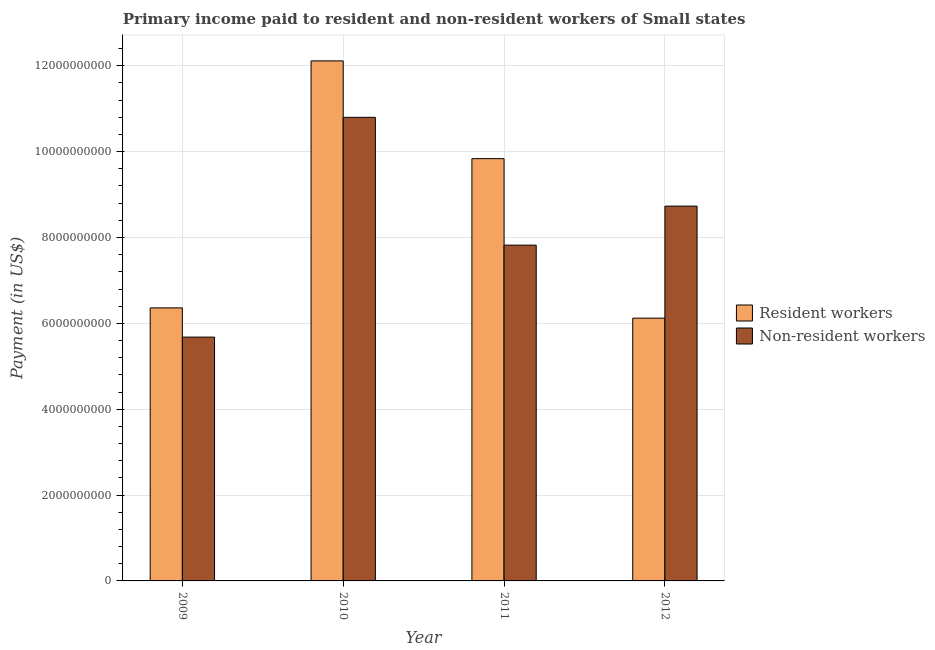How many different coloured bars are there?
Provide a short and direct response. 2. How many groups of bars are there?
Make the answer very short. 4. Are the number of bars per tick equal to the number of legend labels?
Your answer should be compact. Yes. Are the number of bars on each tick of the X-axis equal?
Provide a short and direct response. Yes. How many bars are there on the 3rd tick from the left?
Your response must be concise. 2. What is the label of the 2nd group of bars from the left?
Give a very brief answer. 2010. What is the payment made to resident workers in 2012?
Make the answer very short. 6.12e+09. Across all years, what is the maximum payment made to resident workers?
Offer a terse response. 1.21e+1. Across all years, what is the minimum payment made to non-resident workers?
Your answer should be very brief. 5.68e+09. In which year was the payment made to non-resident workers maximum?
Your answer should be compact. 2010. What is the total payment made to non-resident workers in the graph?
Provide a succinct answer. 3.30e+1. What is the difference between the payment made to non-resident workers in 2010 and that in 2011?
Keep it short and to the point. 2.98e+09. What is the difference between the payment made to non-resident workers in 2010 and the payment made to resident workers in 2009?
Your answer should be very brief. 5.12e+09. What is the average payment made to non-resident workers per year?
Provide a short and direct response. 8.26e+09. In how many years, is the payment made to resident workers greater than 10400000000 US$?
Your response must be concise. 1. What is the ratio of the payment made to non-resident workers in 2010 to that in 2011?
Offer a very short reply. 1.38. Is the payment made to resident workers in 2010 less than that in 2012?
Your answer should be very brief. No. What is the difference between the highest and the second highest payment made to non-resident workers?
Provide a succinct answer. 2.07e+09. What is the difference between the highest and the lowest payment made to non-resident workers?
Keep it short and to the point. 5.12e+09. What does the 1st bar from the left in 2011 represents?
Ensure brevity in your answer.  Resident workers. What does the 2nd bar from the right in 2010 represents?
Ensure brevity in your answer.  Resident workers. How many bars are there?
Offer a terse response. 8. How many years are there in the graph?
Your answer should be very brief. 4. Does the graph contain grids?
Your answer should be compact. Yes. What is the title of the graph?
Offer a very short reply. Primary income paid to resident and non-resident workers of Small states. What is the label or title of the Y-axis?
Your response must be concise. Payment (in US$). What is the Payment (in US$) in Resident workers in 2009?
Ensure brevity in your answer.  6.36e+09. What is the Payment (in US$) of Non-resident workers in 2009?
Give a very brief answer. 5.68e+09. What is the Payment (in US$) in Resident workers in 2010?
Provide a succinct answer. 1.21e+1. What is the Payment (in US$) in Non-resident workers in 2010?
Your answer should be compact. 1.08e+1. What is the Payment (in US$) of Resident workers in 2011?
Make the answer very short. 9.84e+09. What is the Payment (in US$) of Non-resident workers in 2011?
Your answer should be compact. 7.82e+09. What is the Payment (in US$) of Resident workers in 2012?
Keep it short and to the point. 6.12e+09. What is the Payment (in US$) in Non-resident workers in 2012?
Provide a short and direct response. 8.73e+09. Across all years, what is the maximum Payment (in US$) in Resident workers?
Ensure brevity in your answer.  1.21e+1. Across all years, what is the maximum Payment (in US$) in Non-resident workers?
Offer a terse response. 1.08e+1. Across all years, what is the minimum Payment (in US$) in Resident workers?
Your answer should be compact. 6.12e+09. Across all years, what is the minimum Payment (in US$) of Non-resident workers?
Provide a succinct answer. 5.68e+09. What is the total Payment (in US$) of Resident workers in the graph?
Your answer should be very brief. 3.44e+1. What is the total Payment (in US$) in Non-resident workers in the graph?
Offer a very short reply. 3.30e+1. What is the difference between the Payment (in US$) in Resident workers in 2009 and that in 2010?
Give a very brief answer. -5.75e+09. What is the difference between the Payment (in US$) in Non-resident workers in 2009 and that in 2010?
Your response must be concise. -5.12e+09. What is the difference between the Payment (in US$) in Resident workers in 2009 and that in 2011?
Give a very brief answer. -3.48e+09. What is the difference between the Payment (in US$) of Non-resident workers in 2009 and that in 2011?
Your answer should be very brief. -2.14e+09. What is the difference between the Payment (in US$) in Resident workers in 2009 and that in 2012?
Give a very brief answer. 2.39e+08. What is the difference between the Payment (in US$) of Non-resident workers in 2009 and that in 2012?
Your response must be concise. -3.05e+09. What is the difference between the Payment (in US$) of Resident workers in 2010 and that in 2011?
Your response must be concise. 2.28e+09. What is the difference between the Payment (in US$) of Non-resident workers in 2010 and that in 2011?
Give a very brief answer. 2.98e+09. What is the difference between the Payment (in US$) of Resident workers in 2010 and that in 2012?
Ensure brevity in your answer.  5.99e+09. What is the difference between the Payment (in US$) of Non-resident workers in 2010 and that in 2012?
Give a very brief answer. 2.07e+09. What is the difference between the Payment (in US$) of Resident workers in 2011 and that in 2012?
Offer a very short reply. 3.72e+09. What is the difference between the Payment (in US$) in Non-resident workers in 2011 and that in 2012?
Give a very brief answer. -9.08e+08. What is the difference between the Payment (in US$) of Resident workers in 2009 and the Payment (in US$) of Non-resident workers in 2010?
Your response must be concise. -4.44e+09. What is the difference between the Payment (in US$) of Resident workers in 2009 and the Payment (in US$) of Non-resident workers in 2011?
Give a very brief answer. -1.46e+09. What is the difference between the Payment (in US$) of Resident workers in 2009 and the Payment (in US$) of Non-resident workers in 2012?
Offer a terse response. -2.37e+09. What is the difference between the Payment (in US$) in Resident workers in 2010 and the Payment (in US$) in Non-resident workers in 2011?
Offer a terse response. 4.29e+09. What is the difference between the Payment (in US$) of Resident workers in 2010 and the Payment (in US$) of Non-resident workers in 2012?
Your response must be concise. 3.38e+09. What is the difference between the Payment (in US$) in Resident workers in 2011 and the Payment (in US$) in Non-resident workers in 2012?
Make the answer very short. 1.11e+09. What is the average Payment (in US$) of Resident workers per year?
Offer a terse response. 8.61e+09. What is the average Payment (in US$) in Non-resident workers per year?
Provide a short and direct response. 8.26e+09. In the year 2009, what is the difference between the Payment (in US$) in Resident workers and Payment (in US$) in Non-resident workers?
Offer a terse response. 6.81e+08. In the year 2010, what is the difference between the Payment (in US$) in Resident workers and Payment (in US$) in Non-resident workers?
Your answer should be compact. 1.31e+09. In the year 2011, what is the difference between the Payment (in US$) of Resident workers and Payment (in US$) of Non-resident workers?
Your response must be concise. 2.02e+09. In the year 2012, what is the difference between the Payment (in US$) of Resident workers and Payment (in US$) of Non-resident workers?
Ensure brevity in your answer.  -2.61e+09. What is the ratio of the Payment (in US$) in Resident workers in 2009 to that in 2010?
Offer a terse response. 0.53. What is the ratio of the Payment (in US$) in Non-resident workers in 2009 to that in 2010?
Provide a short and direct response. 0.53. What is the ratio of the Payment (in US$) of Resident workers in 2009 to that in 2011?
Your response must be concise. 0.65. What is the ratio of the Payment (in US$) of Non-resident workers in 2009 to that in 2011?
Ensure brevity in your answer.  0.73. What is the ratio of the Payment (in US$) of Resident workers in 2009 to that in 2012?
Ensure brevity in your answer.  1.04. What is the ratio of the Payment (in US$) of Non-resident workers in 2009 to that in 2012?
Offer a terse response. 0.65. What is the ratio of the Payment (in US$) in Resident workers in 2010 to that in 2011?
Offer a terse response. 1.23. What is the ratio of the Payment (in US$) of Non-resident workers in 2010 to that in 2011?
Your answer should be compact. 1.38. What is the ratio of the Payment (in US$) in Resident workers in 2010 to that in 2012?
Your answer should be compact. 1.98. What is the ratio of the Payment (in US$) of Non-resident workers in 2010 to that in 2012?
Keep it short and to the point. 1.24. What is the ratio of the Payment (in US$) in Resident workers in 2011 to that in 2012?
Make the answer very short. 1.61. What is the ratio of the Payment (in US$) of Non-resident workers in 2011 to that in 2012?
Provide a succinct answer. 0.9. What is the difference between the highest and the second highest Payment (in US$) of Resident workers?
Give a very brief answer. 2.28e+09. What is the difference between the highest and the second highest Payment (in US$) of Non-resident workers?
Give a very brief answer. 2.07e+09. What is the difference between the highest and the lowest Payment (in US$) of Resident workers?
Make the answer very short. 5.99e+09. What is the difference between the highest and the lowest Payment (in US$) of Non-resident workers?
Your answer should be compact. 5.12e+09. 